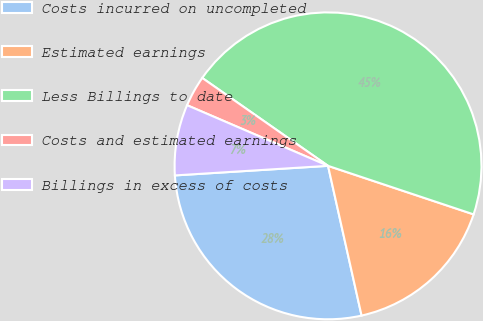Convert chart. <chart><loc_0><loc_0><loc_500><loc_500><pie_chart><fcel>Costs incurred on uncompleted<fcel>Estimated earnings<fcel>Less Billings to date<fcel>Costs and estimated earnings<fcel>Billings in excess of costs<nl><fcel>27.51%<fcel>16.37%<fcel>45.41%<fcel>3.24%<fcel>7.46%<nl></chart> 